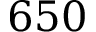<formula> <loc_0><loc_0><loc_500><loc_500>6 5 0</formula> 